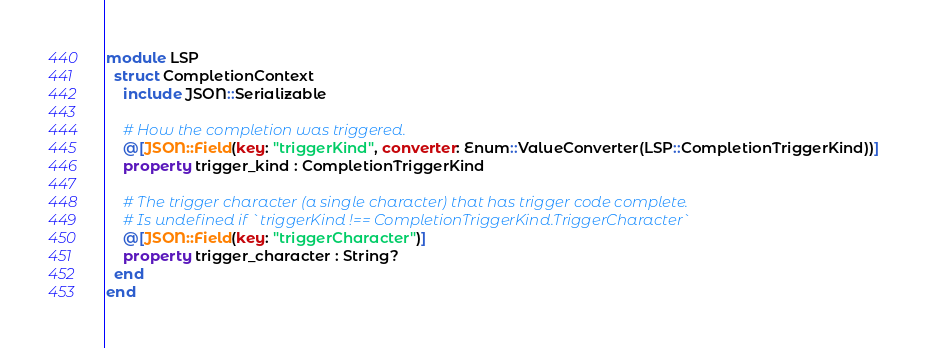Convert code to text. <code><loc_0><loc_0><loc_500><loc_500><_Crystal_>module LSP
  struct CompletionContext
    include JSON::Serializable

    # How the completion was triggered.
    @[JSON::Field(key: "triggerKind", converter: Enum::ValueConverter(LSP::CompletionTriggerKind))]
    property trigger_kind : CompletionTriggerKind

    # The trigger character (a single character) that has trigger code complete.
    # Is undefined if `triggerKind !== CompletionTriggerKind.TriggerCharacter`
    @[JSON::Field(key: "triggerCharacter")]
    property trigger_character : String?
  end
end
</code> 